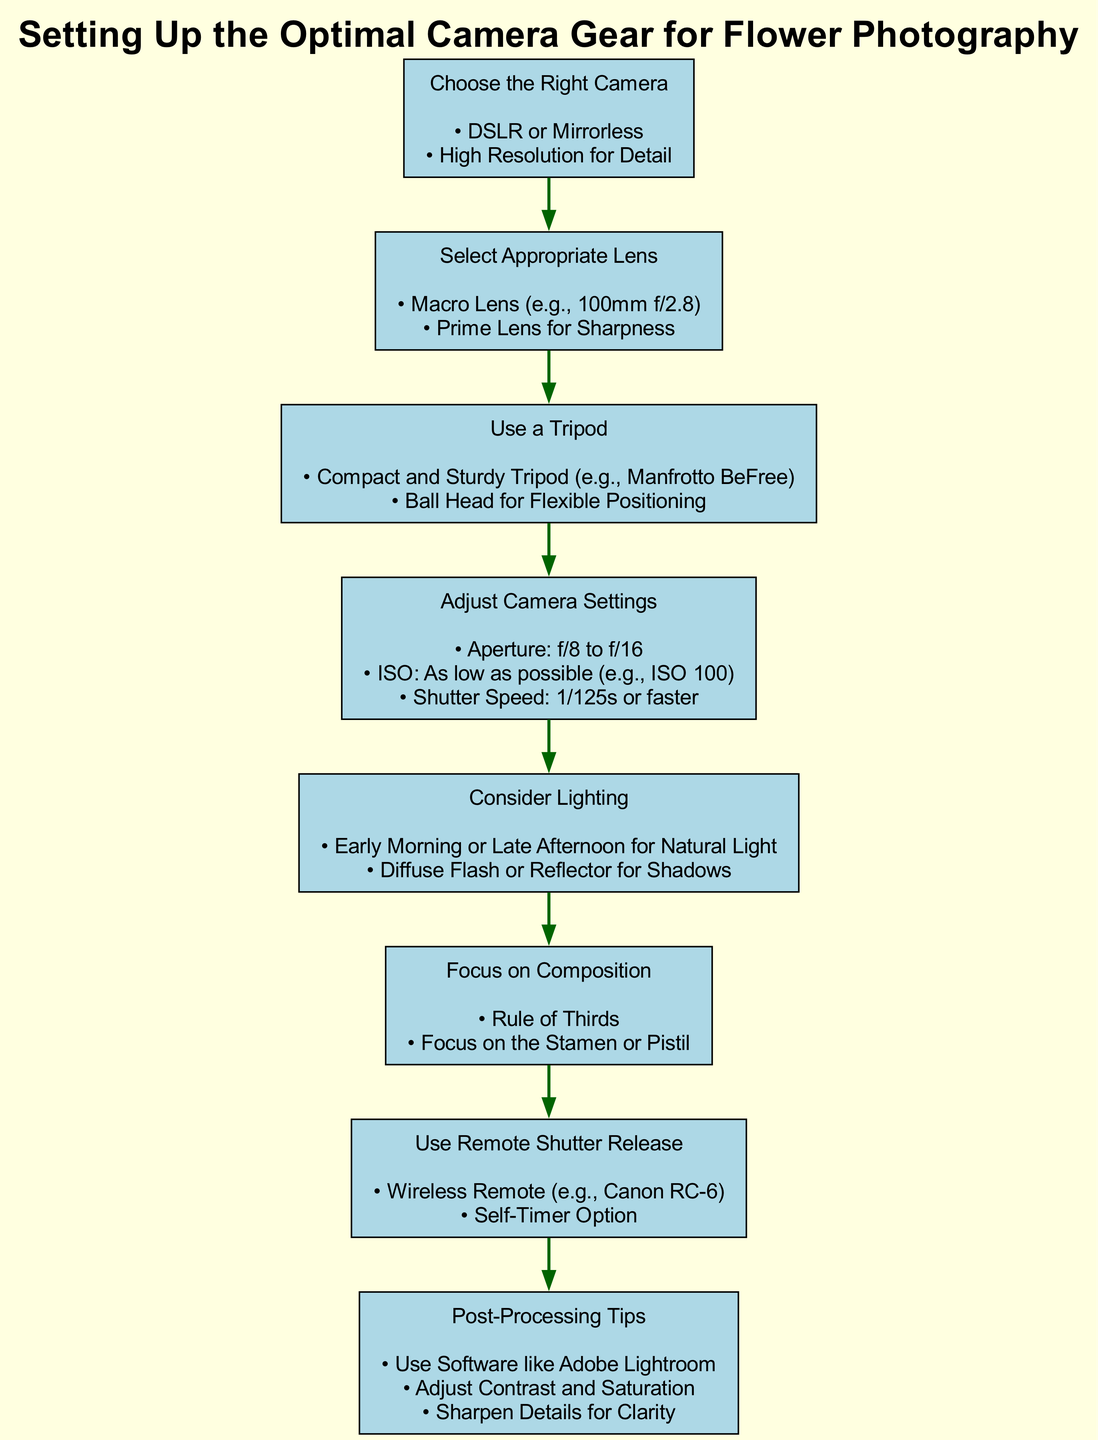What is the first step in the diagram? The diagram lists the first step as "Choose the Right Camera," which I can see is the top node of the flow chart.
Answer: Choose the Right Camera How many total steps are shown in the diagram? By counting the nodes in the diagram, there are eight distinct steps listed, each corresponding to a node connected in sequence.
Answer: Eight What type of lens is recommended for flower photography? The diagram suggests a "Macro Lens (e.g., 100mm f/2.8)" as the appropriate lens for capturing detail in flowers.
Answer: Macro Lens (e.g., 100mm f/2.8) What camera setting is suggested for the aperture? The recommended aperture setting in the diagram is "f/8 to f/16," which helps to achieve depth of field in flower photography.
Answer: f/8 to f/16 Which step follows the "Adjust Camera Settings" step? According to the flow of the diagram, the step that follows "Adjust Camera Settings" is "Consider Lighting."
Answer: Consider Lighting What is the purpose of using a tripod according to the diagram? The diagram emphasizes using a "Compact and Sturdy Tripod" to stabilize the camera, which is crucial when shooting detailed flower images.
Answer: Stabilize the camera What item is suggested for triggering the camera without touching it? The diagram indicates using a "Wireless Remote (e.g., Canon RC-6)" as an option for remotely triggering the camera shutter.
Answer: Wireless Remote (e.g., Canon RC-6) What software is recommended for post-processing? The diagram identifies "Software like Adobe Lightroom" as the suggested tool for post-processing flower photos for adjustments.
Answer: Adobe Lightroom What compositional technique is advised in the diagram? The diagram suggests following the "Rule of Thirds" as a compositional technique to enhance the aesthetics of flower photographs.
Answer: Rule of Thirds 